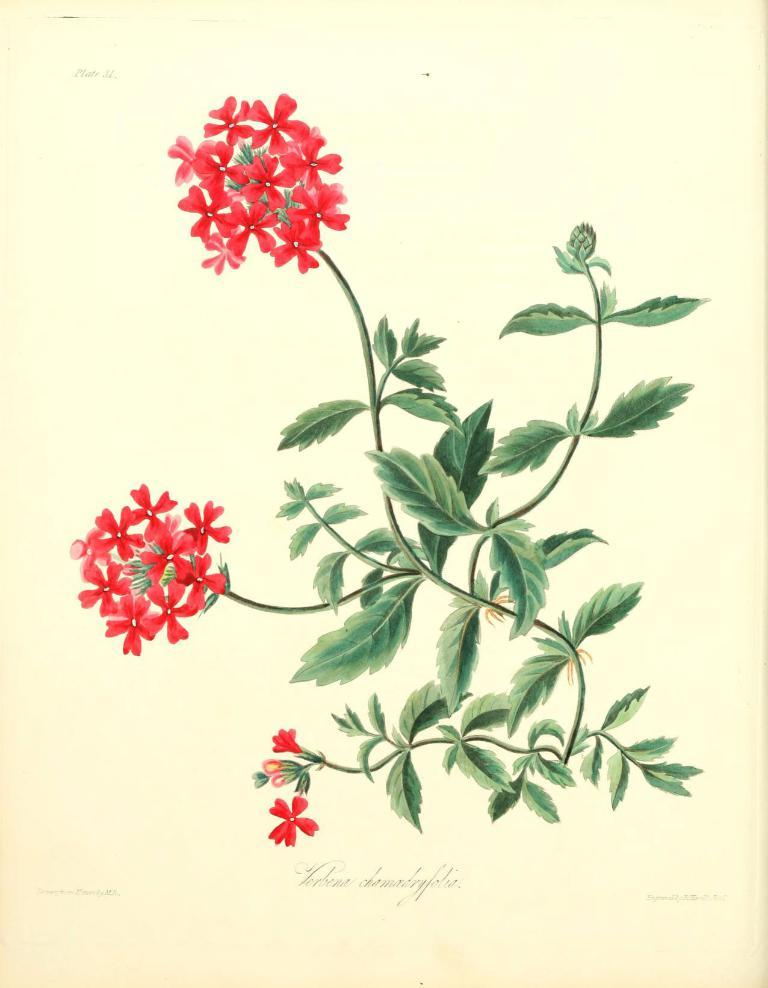What is the main subject of the image? The main subject of the image is a paper. What is depicted on the paper? The paper has drawings or images of flowers. What color are the flowers depicted on the paper? The flowers are depicted as red in color. What color is the paper itself? The paper is depicted as cream in color. How many children are depicted playing with the flowers on the paper? There are no children depicted in the image; it only features a paper with drawings or images of flowers. 